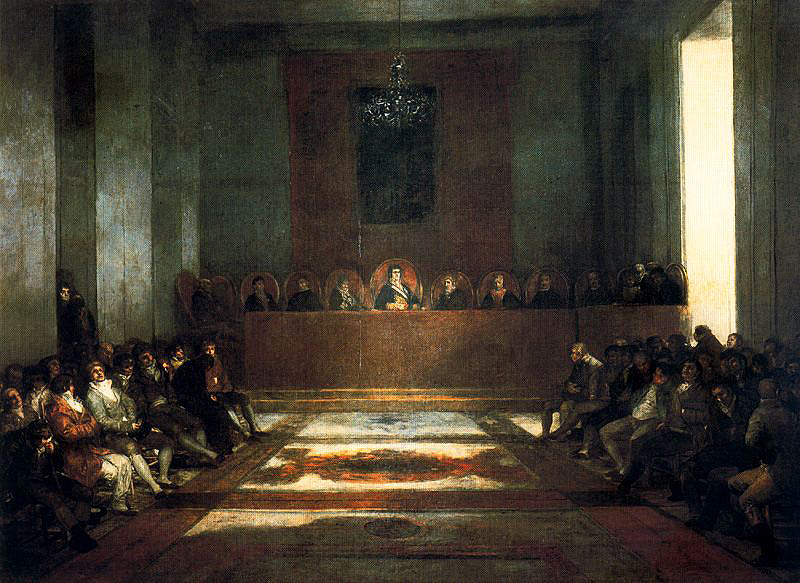How does the use of light in this painting influence the mood or focus? The artist's use of light not only highlights the central figure but also creates a radiant focal point against the otherwise dim surroundings. This strategic lighting brings a divine or mystical quality to the scene, focusing viewers' attention on the main action while also enhancing the somber and reverent mood typical of a religious assembly. 